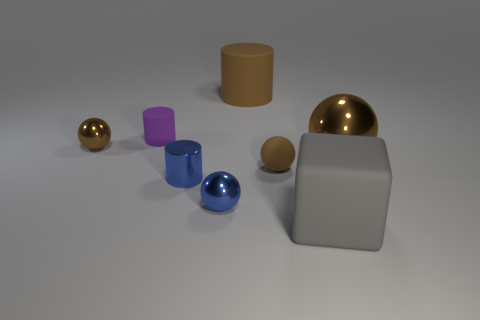How many brown balls must be subtracted to get 1 brown balls? 2 Subtract all yellow blocks. How many brown spheres are left? 3 Add 1 balls. How many objects exist? 9 Subtract all blue balls. How many balls are left? 3 Subtract all large cylinders. How many cylinders are left? 2 Subtract 1 cylinders. How many cylinders are left? 2 Subtract all cylinders. How many objects are left? 5 Subtract all blue balls. Subtract all brown blocks. How many balls are left? 3 Subtract 0 yellow balls. How many objects are left? 8 Subtract all small matte things. Subtract all large things. How many objects are left? 3 